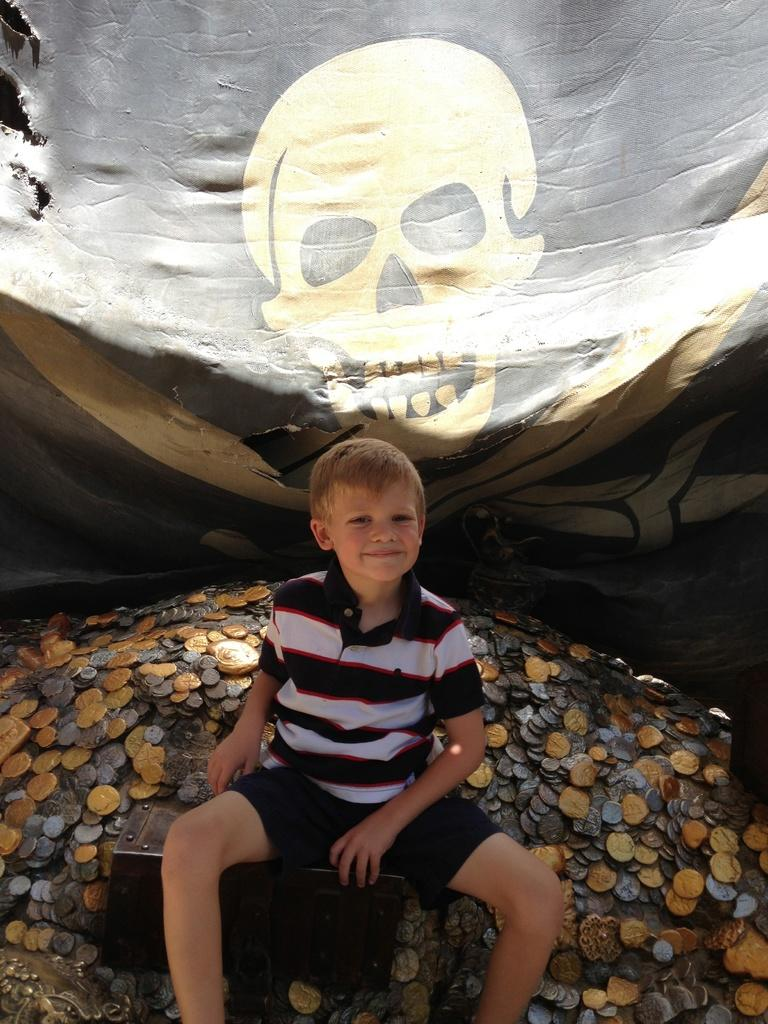Who is the main subject in the image? There is a boy in the image. What is the boy doing in the image? The boy is sitting on a box. What else can be seen in the image besides the boy? There are coins in the image. What is visible in the background of the image? There is a banner in the background of the image, and it has a drawing of a skull on it. What type of canvas is the boy painting in the image? There is no canvas present in the image, and the boy is not shown painting. 